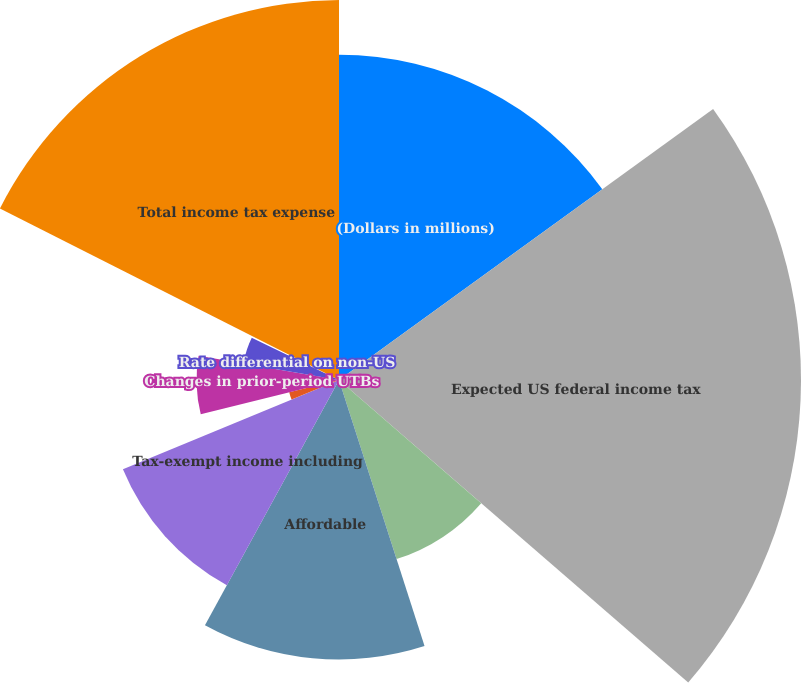Convert chart to OTSL. <chart><loc_0><loc_0><loc_500><loc_500><pie_chart><fcel>(Dollars in millions)<fcel>Expected US federal income tax<fcel>State tax expense net of<fcel>Affordable<fcel>Tax-exempt income including<fcel>Nondeductible expenses<fcel>Changes in prior-period UTBs<fcel>Rate differential on non-US<fcel>Other<fcel>Total income tax expense<nl><fcel>15.02%<fcel>21.34%<fcel>8.69%<fcel>12.91%<fcel>10.8%<fcel>2.37%<fcel>6.58%<fcel>4.48%<fcel>0.26%<fcel>17.55%<nl></chart> 